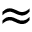Convert formula to latex. <formula><loc_0><loc_0><loc_500><loc_500>\approx</formula> 